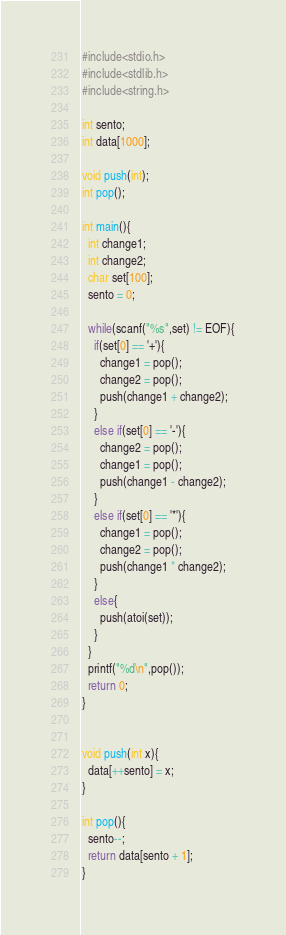Convert code to text. <code><loc_0><loc_0><loc_500><loc_500><_C_>#include<stdio.h>
#include<stdlib.h>
#include<string.h>

int sento;
int data[1000];

void push(int);
int pop();

int main(){
  int change1;
  int change2;
  char set[100];
  sento = 0;

  while(scanf("%s",set) != EOF){
    if(set[0] == '+'){
      change1 = pop();
      change2 = pop();
      push(change1 + change2);
    }
    else if(set[0] == '-'){
      change2 = pop();
      change1 = pop();
      push(change1 - change2);
    }
    else if(set[0] == '*'){
      change1 = pop();
      change2 = pop();
      push(change1 * change2);
    }
    else{
      push(atoi(set));
    }
  }
  printf("%d\n",pop());
  return 0;
}


void push(int x){
  data[++sento] = x;
}

int pop(){
  sento--;
  return data[sento + 1];
}

</code> 